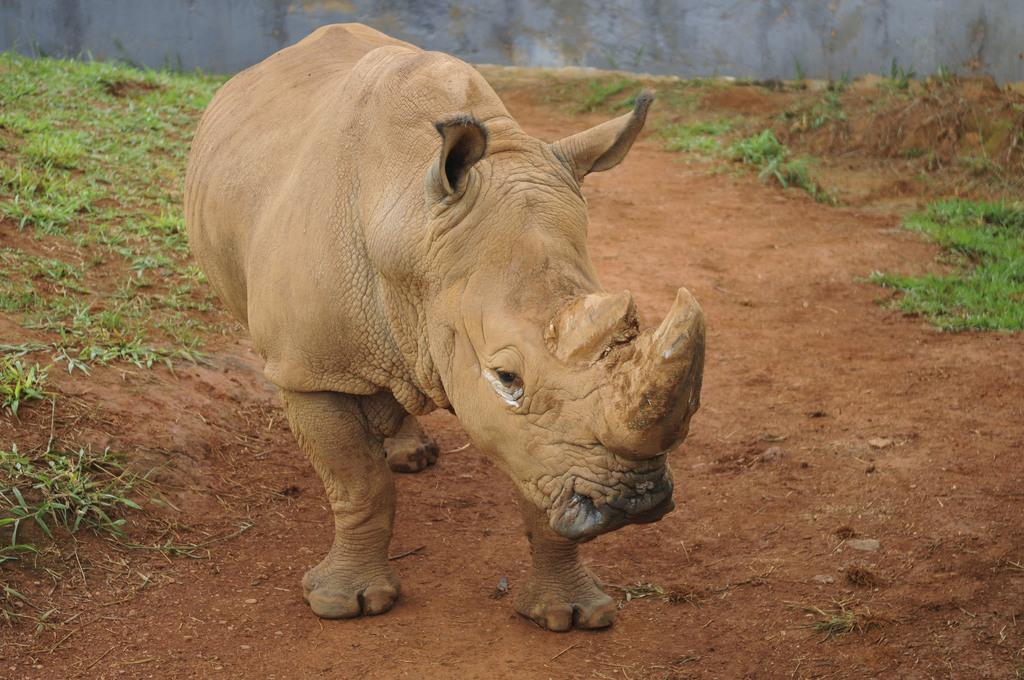What animal is on the ground in the image? There is a rhinoceros on the ground in the image. What type of vegetation is present on both sides of the image? There is grass on the left side and right side of the image. What structure can be seen at the top of the image? There is a wall at the top of the image. What type of teeth does the rhinoceros have in the image? Rhinoceroses do not have teeth visible in the image, as they have a prehensile upper lip and a thick horn on their snout. 